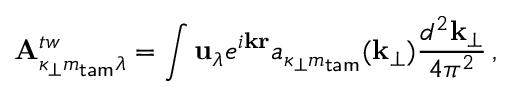Convert formula to latex. <formula><loc_0><loc_0><loc_500><loc_500>{ A } _ { \kappa _ { \perp } m _ { t a m } \lambda } ^ { t w } = \int { u } _ { \lambda } e ^ { i { k r } } a _ { \kappa _ { \perp } m _ { t a m } } ( { k } _ { \perp } ) \frac { d ^ { 2 } { k } _ { \perp } } { 4 \pi ^ { 2 } } \, ,</formula> 